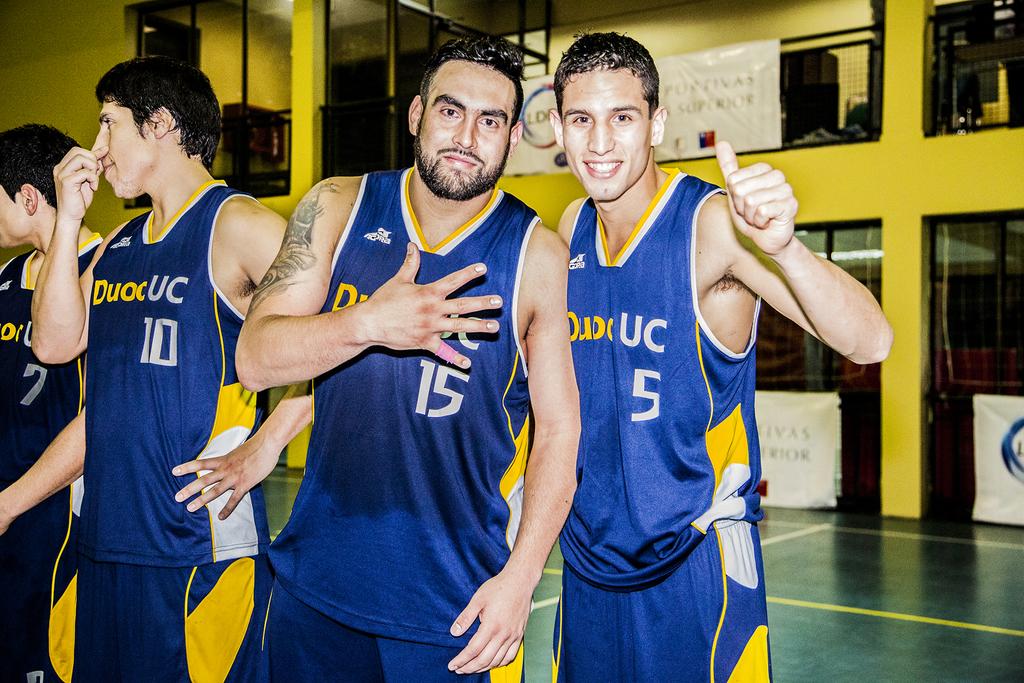What number is the player on the right?
Make the answer very short. 5. What is the number of the player with his hand on his chest?
Offer a terse response. 15. 